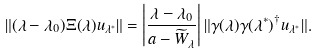Convert formula to latex. <formula><loc_0><loc_0><loc_500><loc_500>\| ( \lambda - \lambda _ { 0 } ) \Xi ( \lambda ) { u } _ { \lambda ^ { * } } \| = \left | \frac { \lambda - \lambda _ { 0 } } { a - \widetilde { W } _ { \lambda } } \right | \| \gamma ( \lambda ) \gamma ( \lambda ^ { * } ) ^ { \dag } { u } _ { \lambda ^ { * } } \| .</formula> 